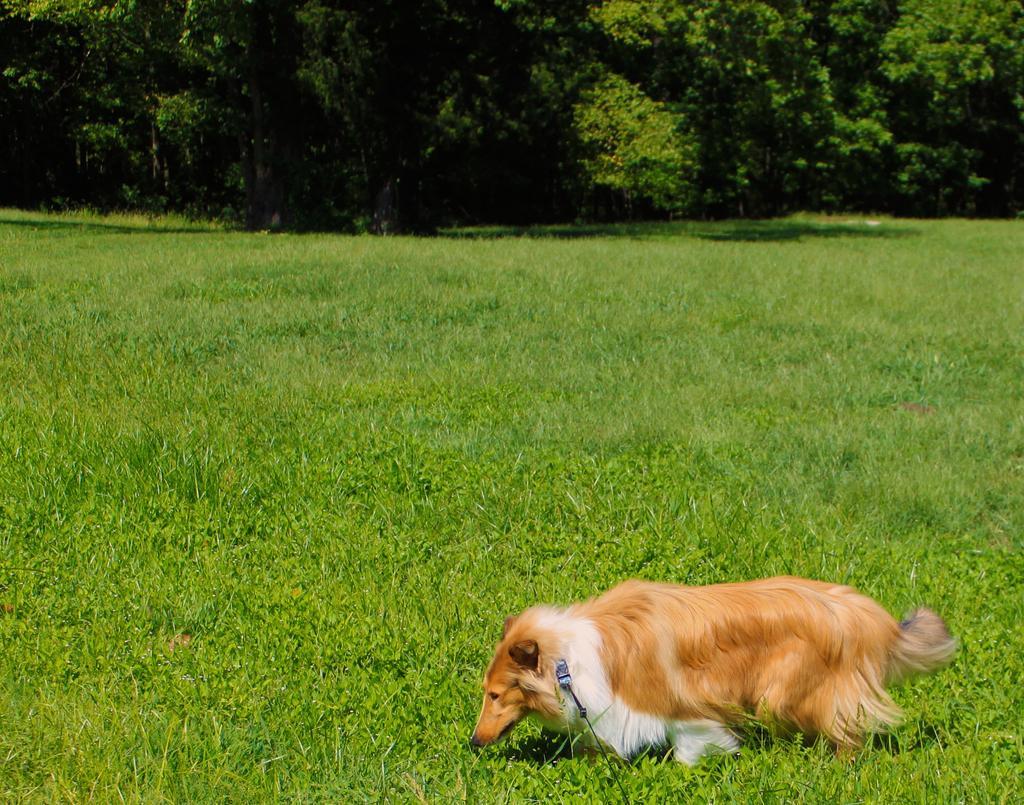How would you summarize this image in a sentence or two? In this picture I can see the animal. I can see the green grass. I can see trees. 